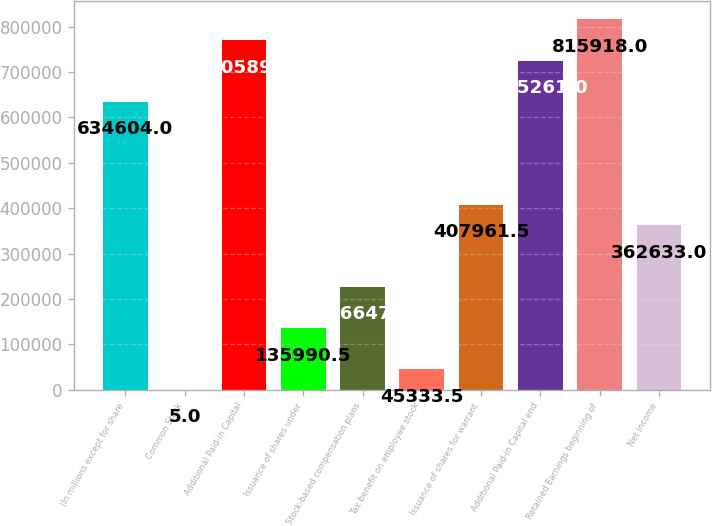Convert chart. <chart><loc_0><loc_0><loc_500><loc_500><bar_chart><fcel>(In millions except for share<fcel>Common Stock<fcel>Additional Paid-in Capital<fcel>Issuance of shares under<fcel>Stock-based compensation plans<fcel>Tax benefit on employee stock<fcel>Issuance of shares for warrant<fcel>Additional Paid-in Capital end<fcel>Retained Earnings beginning of<fcel>Net income<nl><fcel>634604<fcel>5<fcel>770590<fcel>135990<fcel>226648<fcel>45333.5<fcel>407962<fcel>725261<fcel>815918<fcel>362633<nl></chart> 